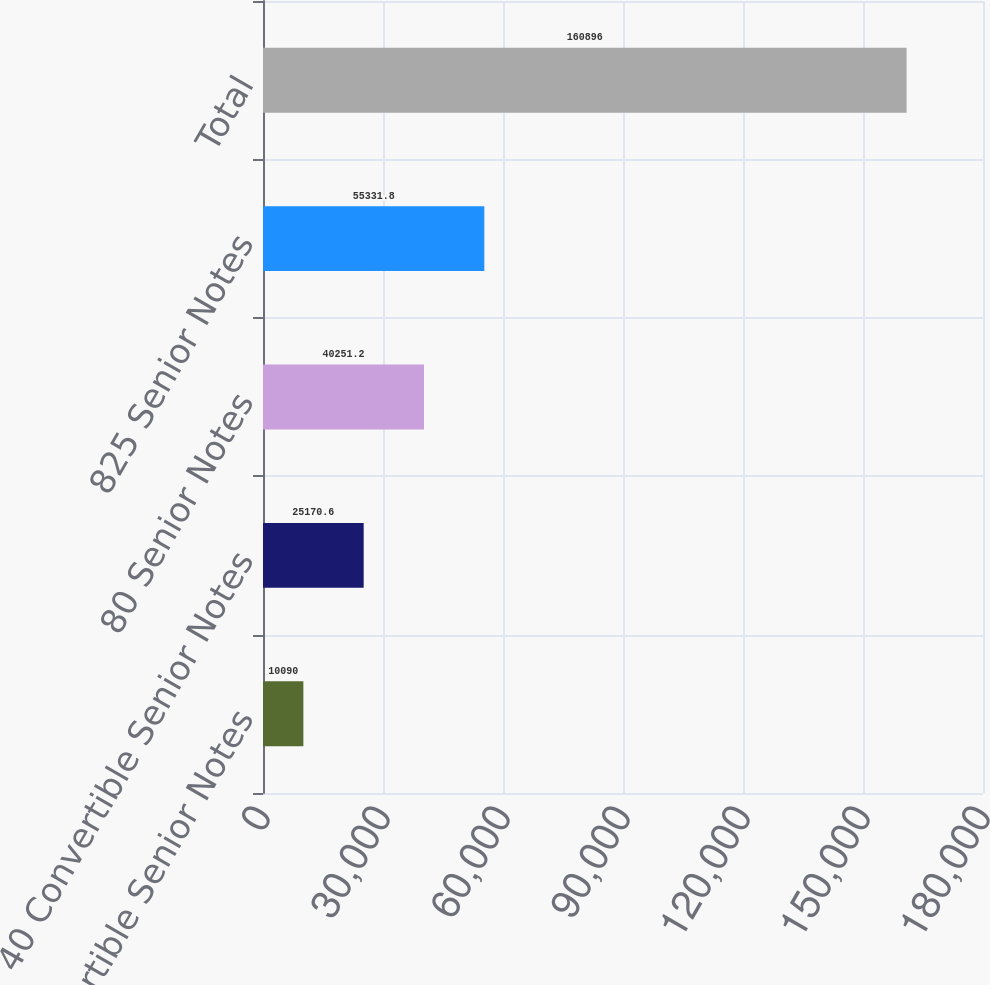Convert chart to OTSL. <chart><loc_0><loc_0><loc_500><loc_500><bar_chart><fcel>1875 Convertible Senior Notes<fcel>40 Convertible Senior Notes<fcel>80 Senior Notes<fcel>825 Senior Notes<fcel>Total<nl><fcel>10090<fcel>25170.6<fcel>40251.2<fcel>55331.8<fcel>160896<nl></chart> 